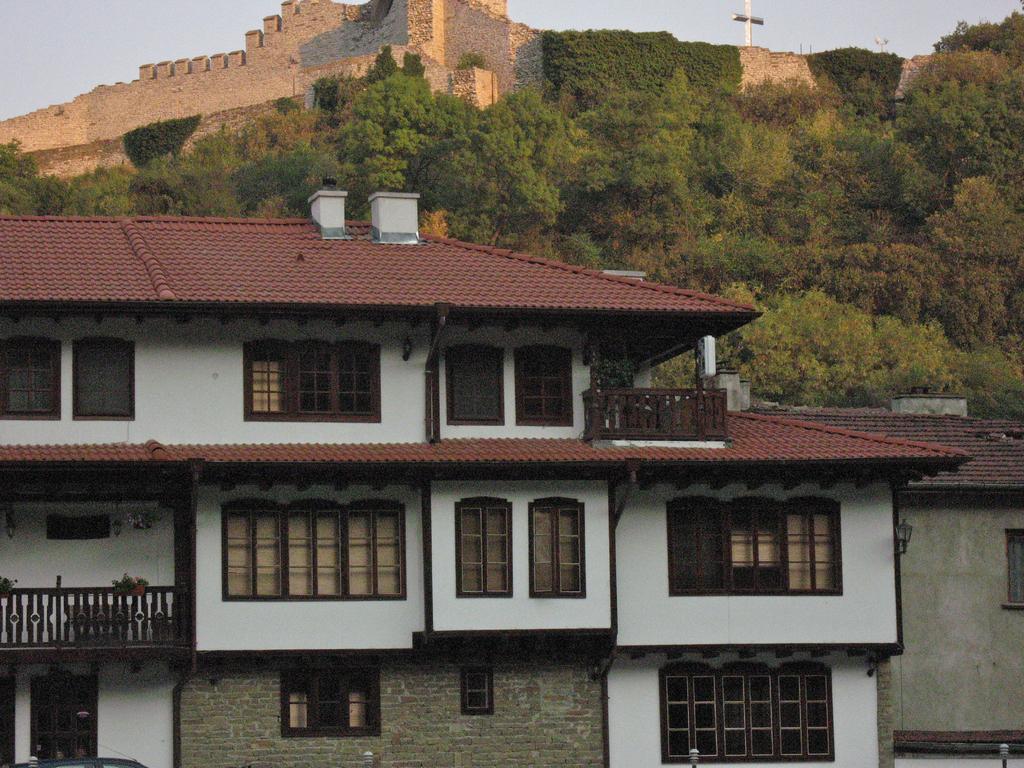Can you describe this image briefly? In this picture there are buildings. On the left side of the image there might be a vehicle and there are plants on the railing. At the back there is a fort and there are trees and there is a sculpture. At the top there is sky. 